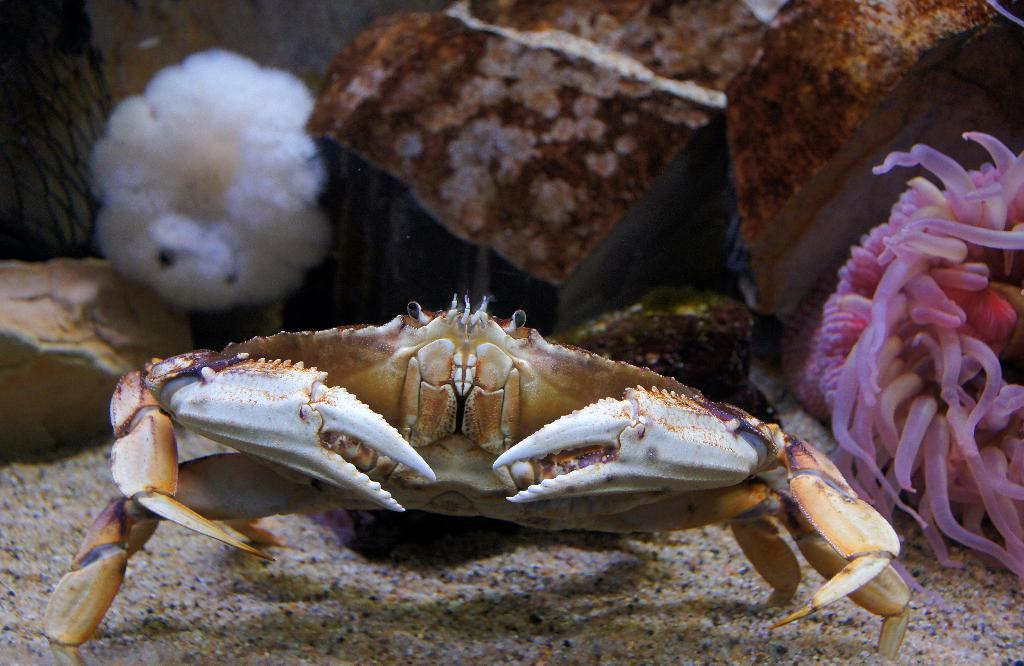What animal can be seen on the ground in the image? There is a crab on the ground in the image. What type of vegetation is visible in the image? There are plants visible in the image. What type of natural formation is present at the top of the image? There are rocks at the top of the image. What type of record is being played by the governor in the image? There is no governor or record present in the image; it features a crab, plants, and rocks. How many snails can be seen crawling on the rocks in the image? There are no snails visible in the image; it only features a crab, plants, and rocks. 